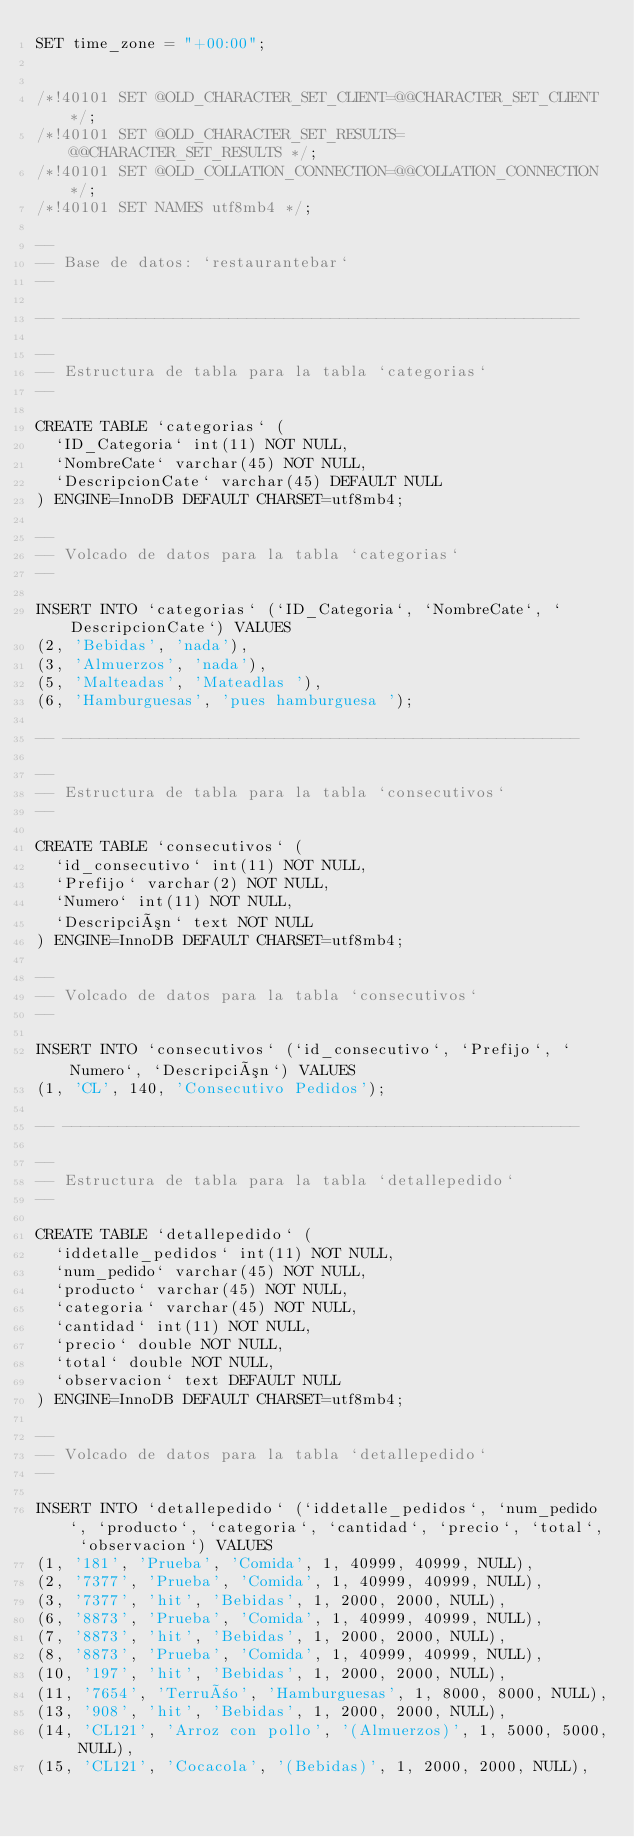<code> <loc_0><loc_0><loc_500><loc_500><_SQL_>SET time_zone = "+00:00";


/*!40101 SET @OLD_CHARACTER_SET_CLIENT=@@CHARACTER_SET_CLIENT */;
/*!40101 SET @OLD_CHARACTER_SET_RESULTS=@@CHARACTER_SET_RESULTS */;
/*!40101 SET @OLD_COLLATION_CONNECTION=@@COLLATION_CONNECTION */;
/*!40101 SET NAMES utf8mb4 */;

--
-- Base de datos: `restaurantebar`
--

-- --------------------------------------------------------

--
-- Estructura de tabla para la tabla `categorias`
--

CREATE TABLE `categorias` (
  `ID_Categoria` int(11) NOT NULL,
  `NombreCate` varchar(45) NOT NULL,
  `DescripcionCate` varchar(45) DEFAULT NULL
) ENGINE=InnoDB DEFAULT CHARSET=utf8mb4;

--
-- Volcado de datos para la tabla `categorias`
--

INSERT INTO `categorias` (`ID_Categoria`, `NombreCate`, `DescripcionCate`) VALUES
(2, 'Bebidas', 'nada'),
(3, 'Almuerzos', 'nada'),
(5, 'Malteadas', 'Mateadlas '),
(6, 'Hamburguesas', 'pues hamburguesa ');

-- --------------------------------------------------------

--
-- Estructura de tabla para la tabla `consecutivos`
--

CREATE TABLE `consecutivos` (
  `id_consecutivo` int(11) NOT NULL,
  `Prefijo` varchar(2) NOT NULL,
  `Numero` int(11) NOT NULL,
  `Descripción` text NOT NULL
) ENGINE=InnoDB DEFAULT CHARSET=utf8mb4;

--
-- Volcado de datos para la tabla `consecutivos`
--

INSERT INTO `consecutivos` (`id_consecutivo`, `Prefijo`, `Numero`, `Descripción`) VALUES
(1, 'CL', 140, 'Consecutivo Pedidos');

-- --------------------------------------------------------

--
-- Estructura de tabla para la tabla `detallepedido`
--

CREATE TABLE `detallepedido` (
  `iddetalle_pedidos` int(11) NOT NULL,
  `num_pedido` varchar(45) NOT NULL,
  `producto` varchar(45) NOT NULL,
  `categoria` varchar(45) NOT NULL,
  `cantidad` int(11) NOT NULL,
  `precio` double NOT NULL,
  `total` double NOT NULL,
  `observacion` text DEFAULT NULL
) ENGINE=InnoDB DEFAULT CHARSET=utf8mb4;

--
-- Volcado de datos para la tabla `detallepedido`
--

INSERT INTO `detallepedido` (`iddetalle_pedidos`, `num_pedido`, `producto`, `categoria`, `cantidad`, `precio`, `total`, `observacion`) VALUES
(1, '181', 'Prueba', 'Comida', 1, 40999, 40999, NULL),
(2, '7377', 'Prueba', 'Comida', 1, 40999, 40999, NULL),
(3, '7377', 'hit', 'Bebidas', 1, 2000, 2000, NULL),
(6, '8873', 'Prueba', 'Comida', 1, 40999, 40999, NULL),
(7, '8873', 'hit', 'Bebidas', 1, 2000, 2000, NULL),
(8, '8873', 'Prueba', 'Comida', 1, 40999, 40999, NULL),
(10, '197', 'hit', 'Bebidas', 1, 2000, 2000, NULL),
(11, '7654', 'Terruño', 'Hamburguesas', 1, 8000, 8000, NULL),
(13, '908', 'hit', 'Bebidas', 1, 2000, 2000, NULL),
(14, 'CL121', 'Arroz con pollo', '(Almuerzos)', 1, 5000, 5000, NULL),
(15, 'CL121', 'Cocacola', '(Bebidas)', 1, 2000, 2000, NULL),</code> 